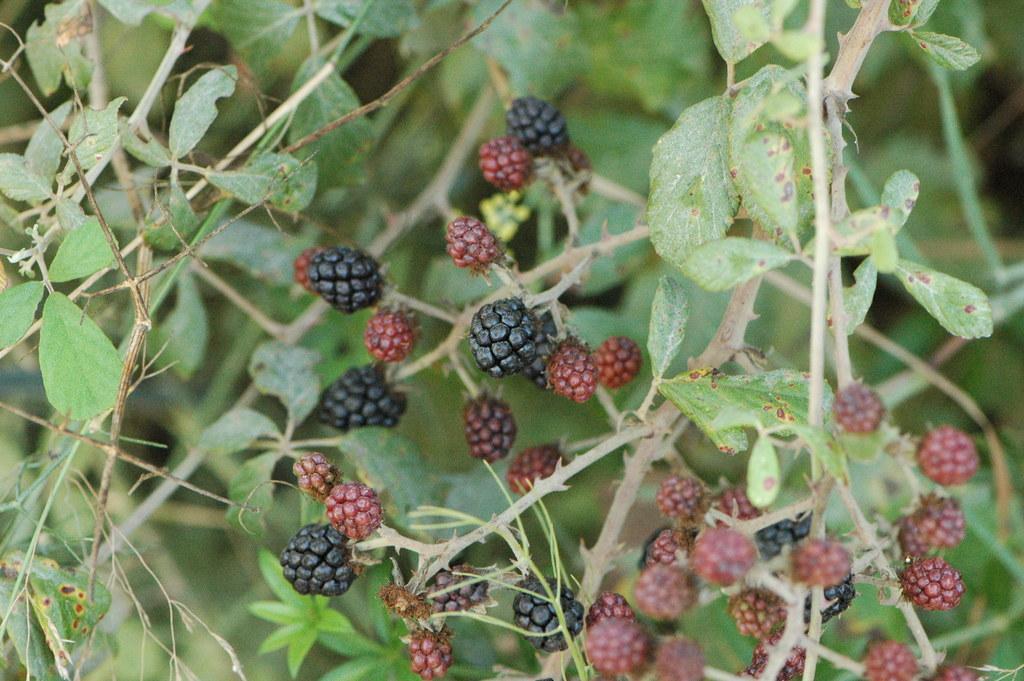Describe this image in one or two sentences. In this image we can see some fruits which are red and black in color, also we can see some plants. 